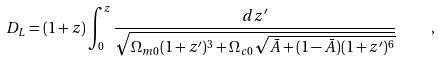<formula> <loc_0><loc_0><loc_500><loc_500>D _ { L } = ( 1 + z ) \int _ { 0 } ^ { z } \frac { d z ^ { \prime } } { \sqrt { \Omega _ { m 0 } ( 1 + z ^ { \prime } ) ^ { 3 } + \Omega _ { c 0 } \sqrt { \bar { A } + ( 1 - \bar { A } ) ( 1 + z ^ { \prime } ) ^ { 6 } } } } \quad ,</formula> 